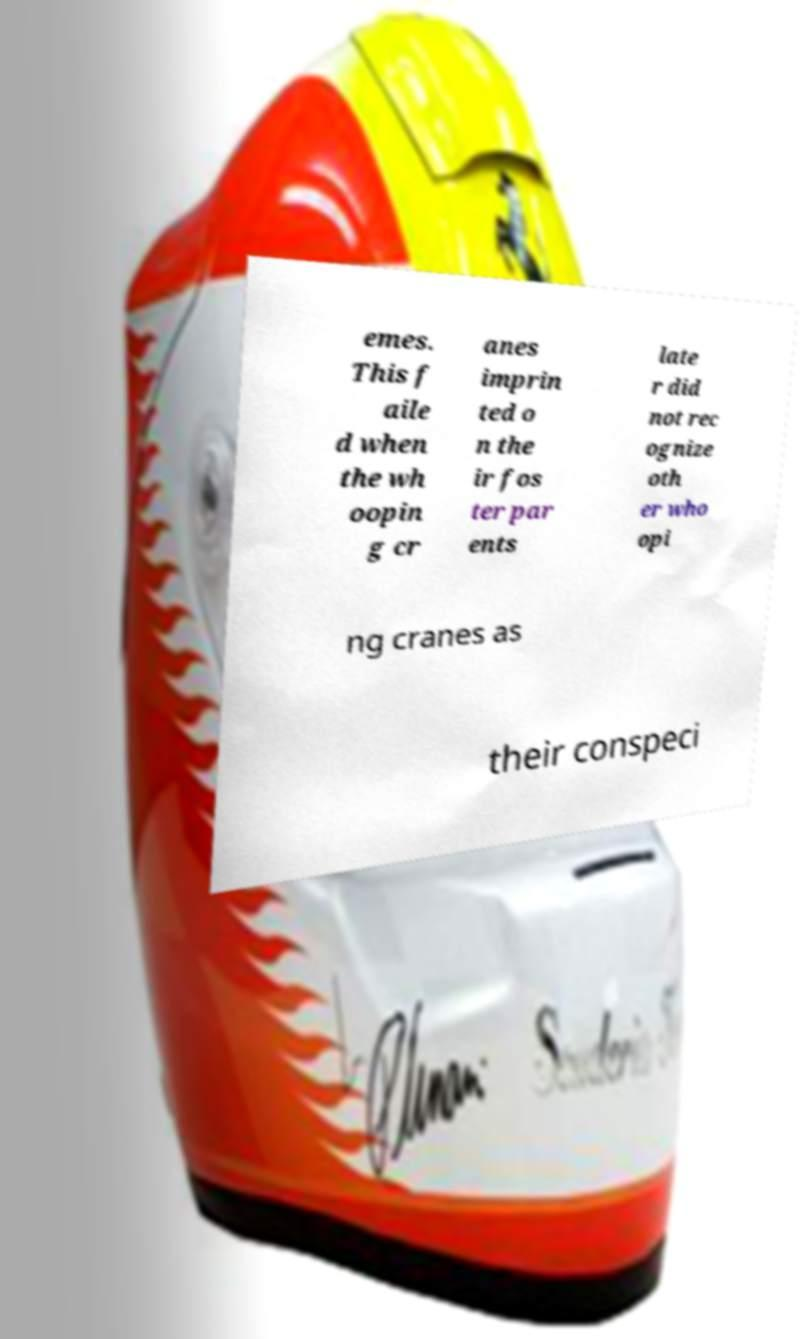Can you read and provide the text displayed in the image?This photo seems to have some interesting text. Can you extract and type it out for me? emes. This f aile d when the wh oopin g cr anes imprin ted o n the ir fos ter par ents late r did not rec ognize oth er who opi ng cranes as their conspeci 